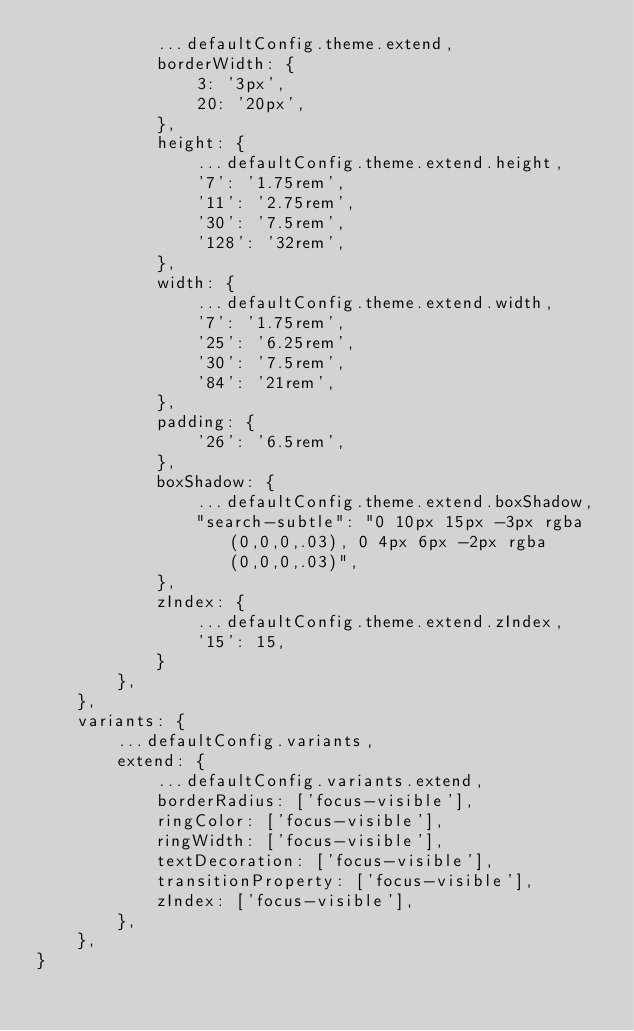<code> <loc_0><loc_0><loc_500><loc_500><_JavaScript_>            ...defaultConfig.theme.extend,
            borderWidth: {
                3: '3px',
                20: '20px',
            },
            height: {
                ...defaultConfig.theme.extend.height,
                '7': '1.75rem',
                '11': '2.75rem',
                '30': '7.5rem',
                '128': '32rem',
            },
            width: {
                ...defaultConfig.theme.extend.width,
                '7': '1.75rem',
                '25': '6.25rem',
                '30': '7.5rem',
                '84': '21rem',
            },
            padding: {
                '26': '6.5rem',
            },
            boxShadow: {
                ...defaultConfig.theme.extend.boxShadow,
                "search-subtle": "0 10px 15px -3px rgba(0,0,0,.03), 0 4px 6px -2px rgba(0,0,0,.03)",
            },
            zIndex: {
                ...defaultConfig.theme.extend.zIndex,
                '15': 15,
            }
        },
    },
    variants: {
        ...defaultConfig.variants,
        extend: {
            ...defaultConfig.variants.extend,
            borderRadius: ['focus-visible'],
            ringColor: ['focus-visible'],
            ringWidth: ['focus-visible'],
            textDecoration: ['focus-visible'],
            transitionProperty: ['focus-visible'],
            zIndex: ['focus-visible'],
        },
    },
}
</code> 